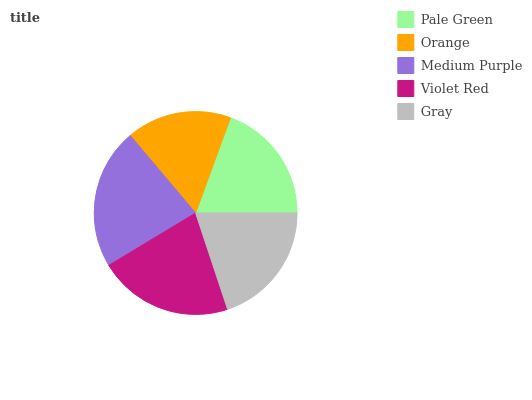Is Orange the minimum?
Answer yes or no. Yes. Is Medium Purple the maximum?
Answer yes or no. Yes. Is Medium Purple the minimum?
Answer yes or no. No. Is Orange the maximum?
Answer yes or no. No. Is Medium Purple greater than Orange?
Answer yes or no. Yes. Is Orange less than Medium Purple?
Answer yes or no. Yes. Is Orange greater than Medium Purple?
Answer yes or no. No. Is Medium Purple less than Orange?
Answer yes or no. No. Is Gray the high median?
Answer yes or no. Yes. Is Gray the low median?
Answer yes or no. Yes. Is Orange the high median?
Answer yes or no. No. Is Pale Green the low median?
Answer yes or no. No. 